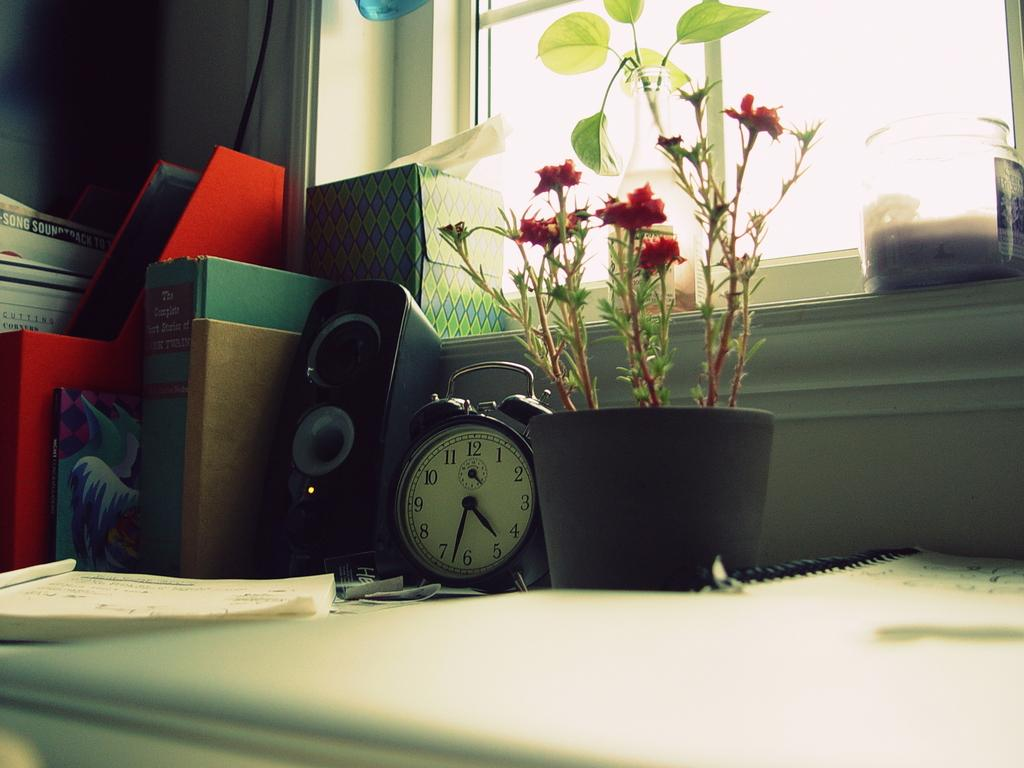<image>
Describe the image concisely. A clock next to a plant reads about 4:32. 